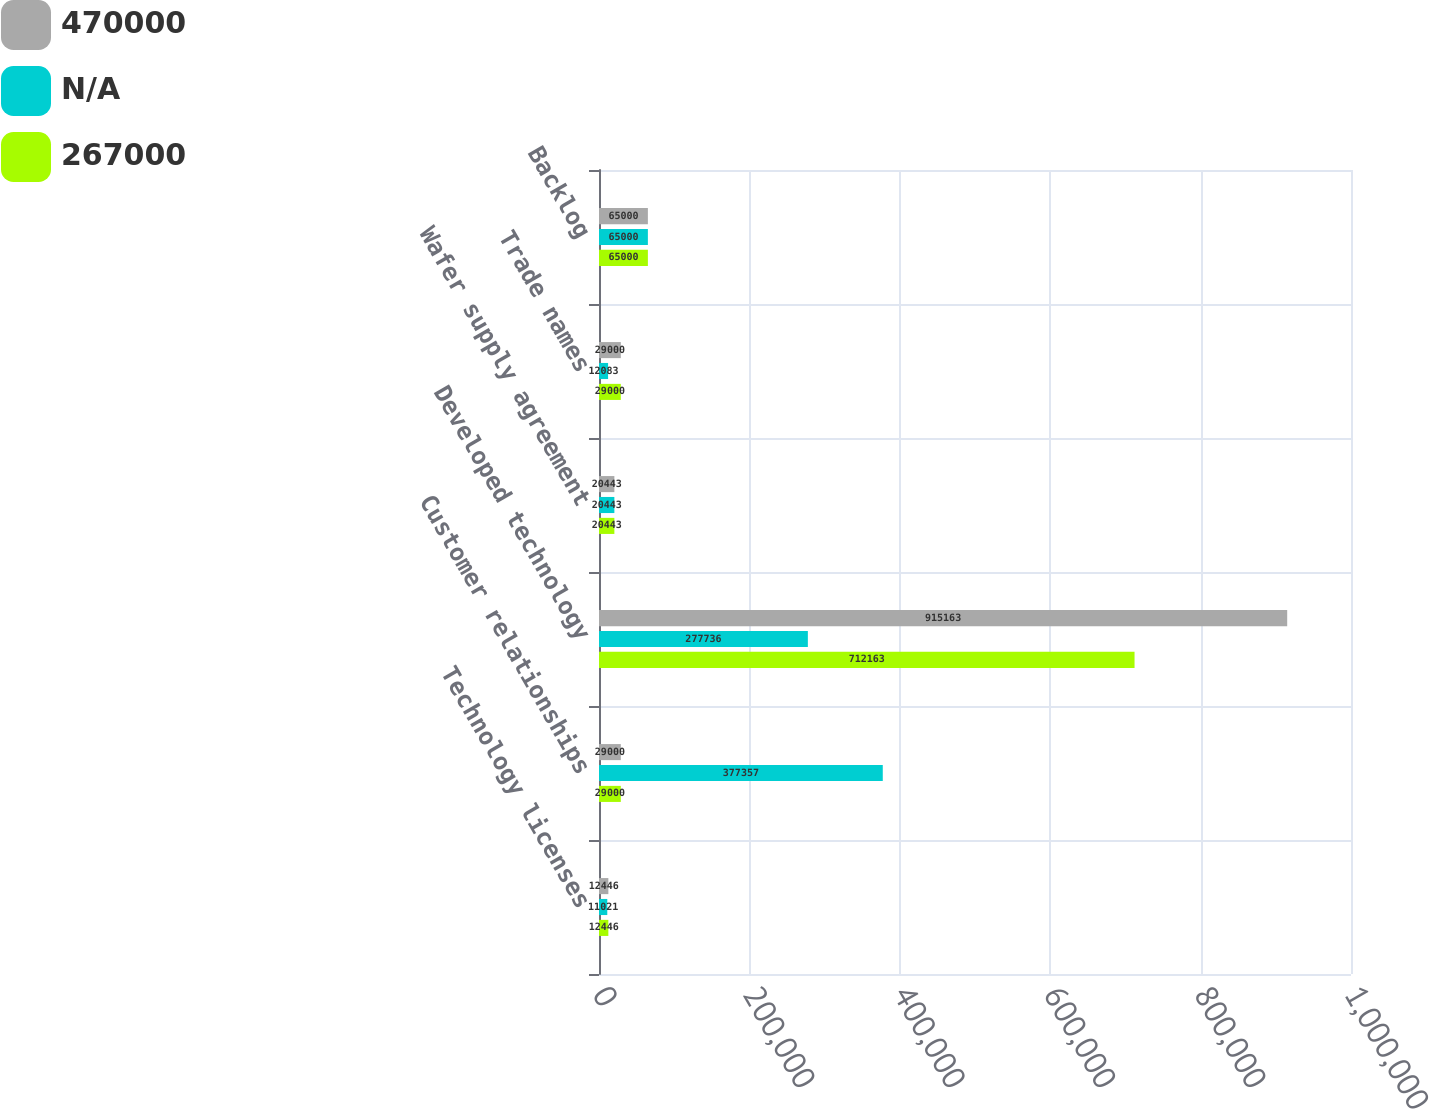Convert chart. <chart><loc_0><loc_0><loc_500><loc_500><stacked_bar_chart><ecel><fcel>Technology licenses<fcel>Customer relationships<fcel>Developed technology<fcel>Wafer supply agreement<fcel>Trade names<fcel>Backlog<nl><fcel>470000<fcel>12446<fcel>29000<fcel>915163<fcel>20443<fcel>29000<fcel>65000<nl><fcel>nan<fcel>11021<fcel>377357<fcel>277736<fcel>20443<fcel>12083<fcel>65000<nl><fcel>267000<fcel>12446<fcel>29000<fcel>712163<fcel>20443<fcel>29000<fcel>65000<nl></chart> 